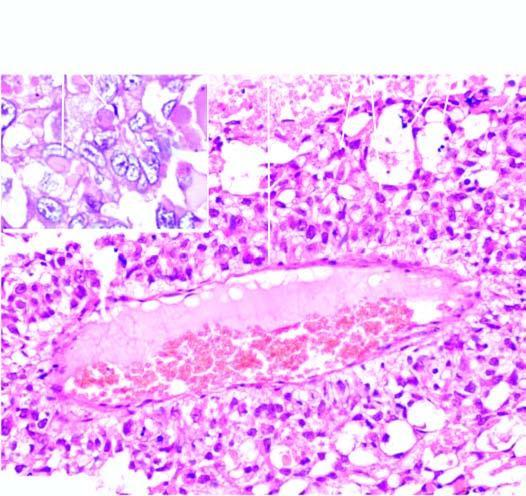re serpiginous ulcers, some deep fissures and swollen intervening surviving mucosa giving 'cobblestone appearance ', present?
Answer the question using a single word or phrase. No 